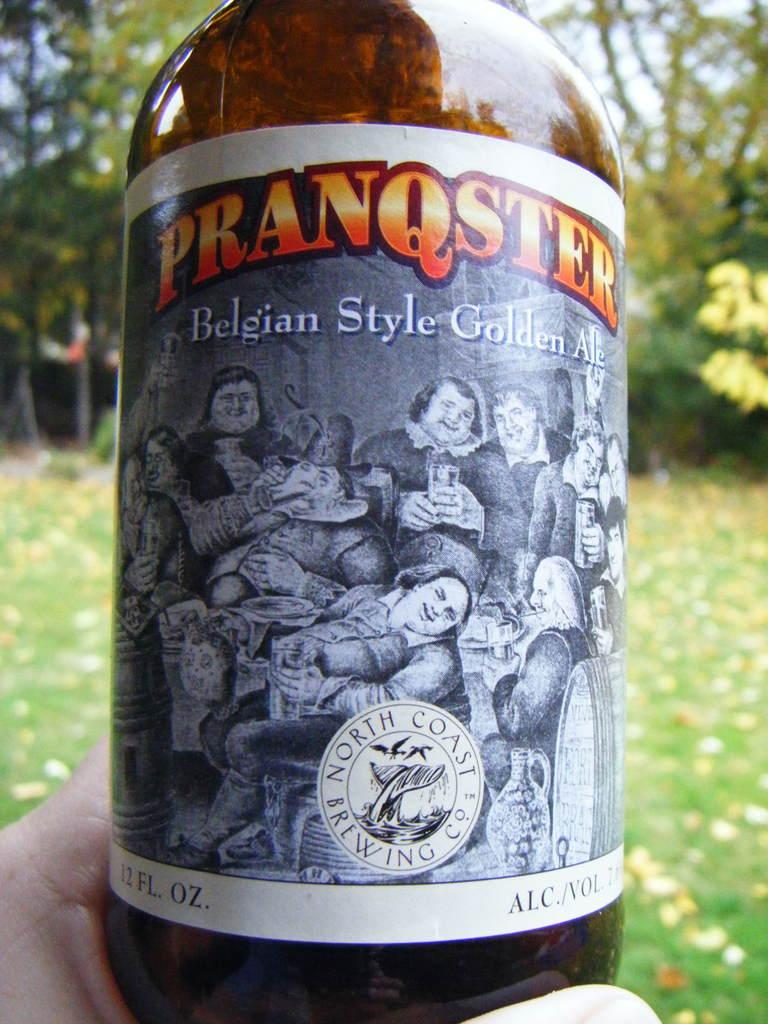<image>
Create a compact narrative representing the image presented. A bottle of beer is Belgian style golden ale. 